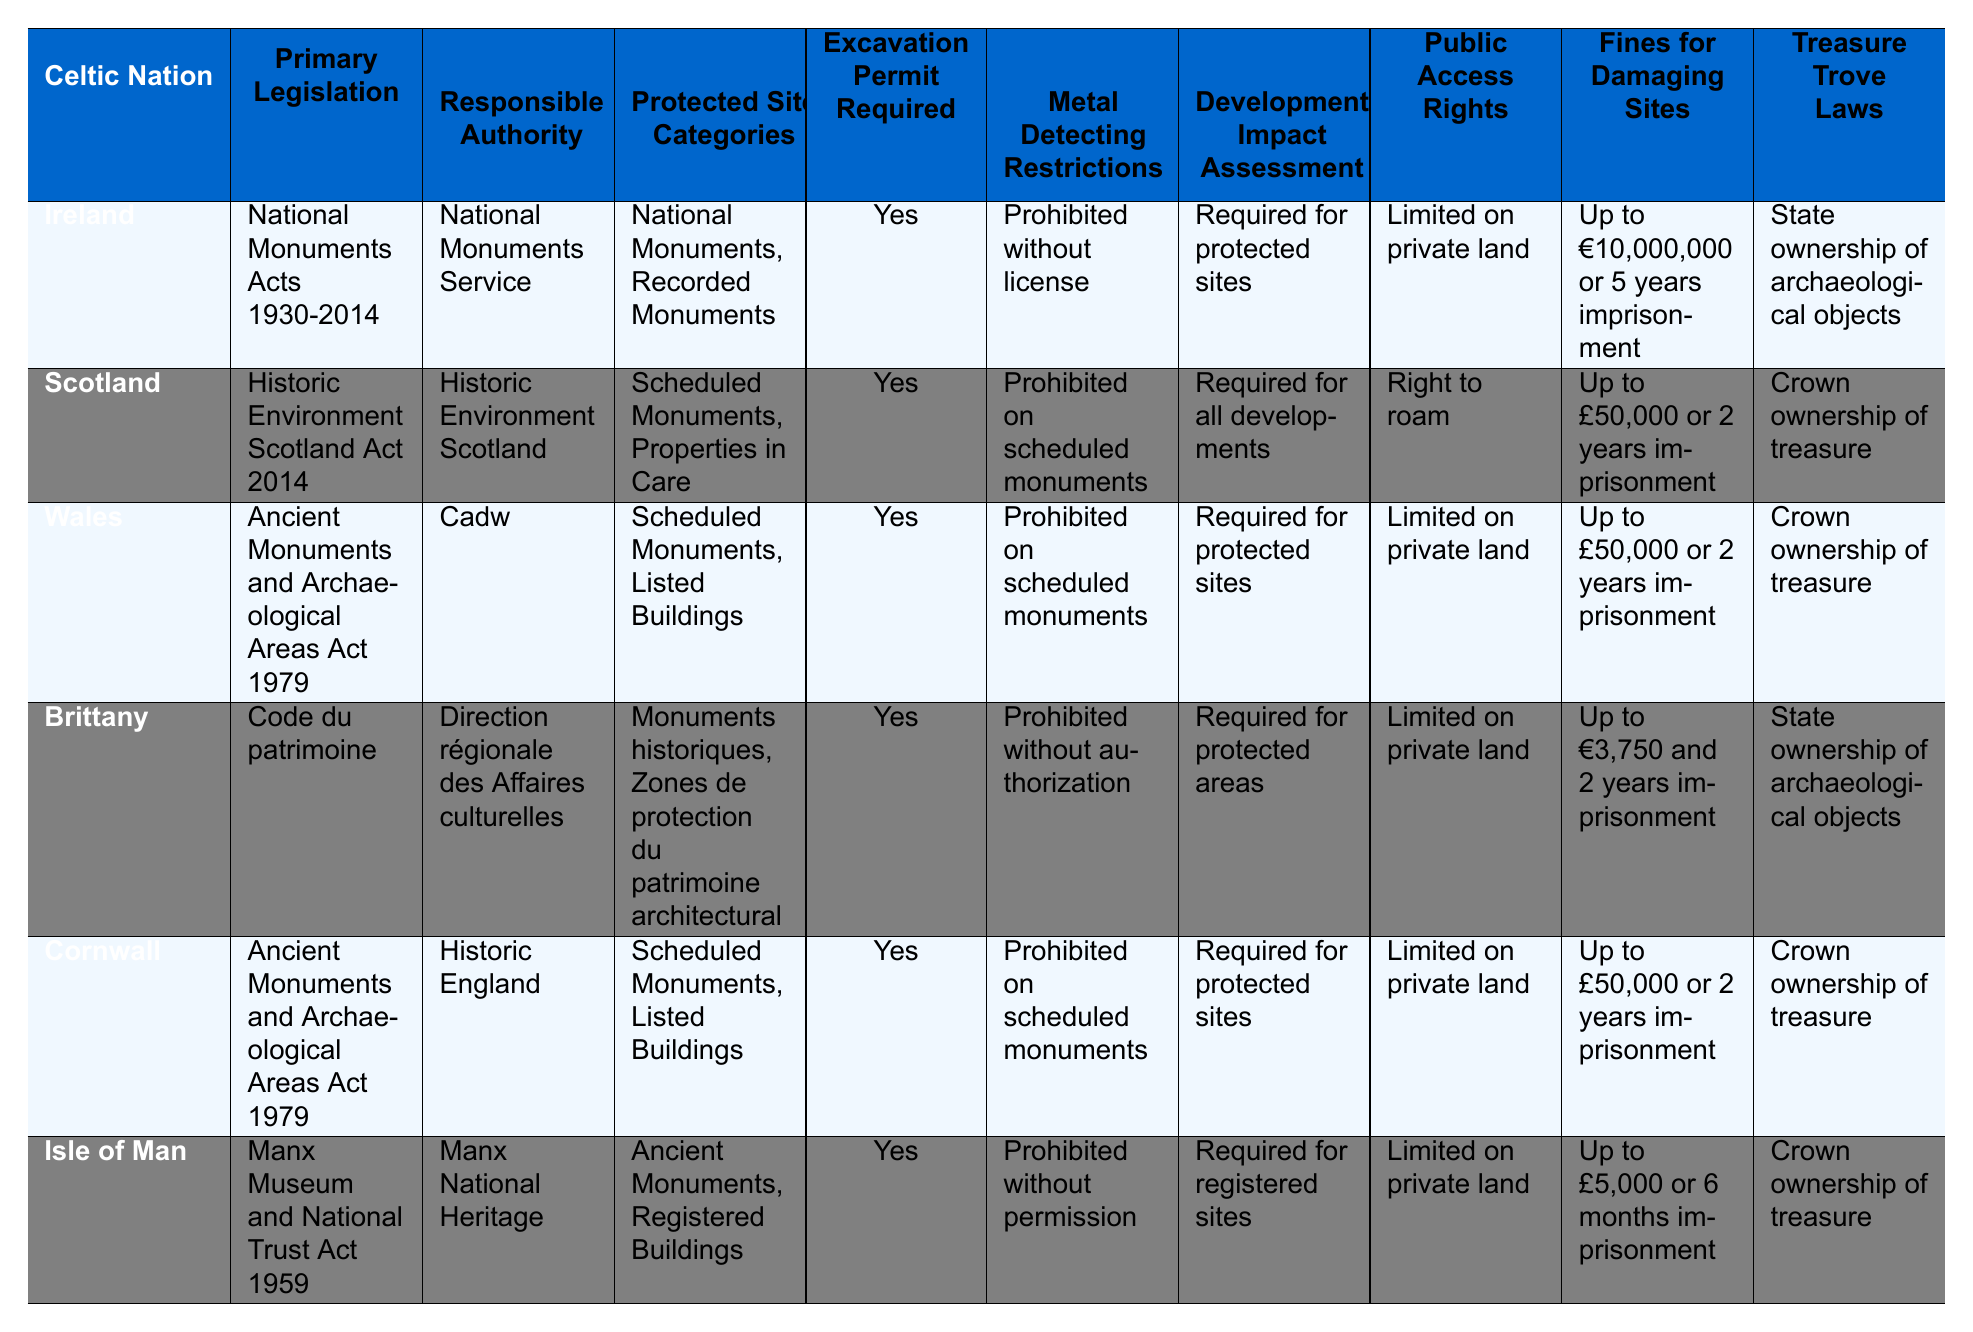What is the primary legislation for protecting archaeological sites in Ireland? The table lists "National Monuments Acts 1930-2014" under the "Primary Legislation" column for Ireland.
Answer: National Monuments Acts 1930-2014 Which Celtic nation has metal detecting restrictions that are "Prohibited without authorization"? In the table, Brittany is indicated to have metal detecting restrictions categorized as "Prohibited without authorization".
Answer: Brittany How many Celtic nations require an excavation permit for archaeological sites? The table shows that all Celtic nations require an excavation permit, as indicated by "Yes" in that column. Since there are six nations, the total is 6.
Answer: 6 What are the fines for damaging archaeological sites in Cornwall? The table states that the fines for damaging sites in Cornwall are "Up to £50,000 or 2 years imprisonment".
Answer: Up to £50,000 or 2 years imprisonment In which Celtic nation is there a right to roam? The table indicates that Scotland is the only Celtic nation listed with "Right to roam" under the "Public Access Rights" column.
Answer: Scotland Which Celtic nation has the least severe fines for damaging archaeological sites? Comparing the fines detailed in the table, the least severe fines belong to the Isle of Man, which states "Up to £5,000 or 6 months imprisonment". This is lower than all other fines listed.
Answer: Isle of Man Do all Celtic nations have the same requirements for development impact assessment? Looking at the table, it shows that while some nations have similar requirements, they are not all the same. Ireland, Wales, and Cornwall require it for protected sites, Scotland for all developments, Brittany for protected areas, and the Isle of Man for registered sites.
Answer: No What is the commonality in treasure trove laws among most Celtic nations? The table shows that all nations except Ireland and Brittany have "Crown ownership of treasure" under their treasure trove laws. Ireland and Brittany state "State ownership of archaeological objects" instead.
Answer: Most Celtic nations have Crown ownership of treasure How do public access rights vary among the Celtic nations? By examining the table, one can see that most Celtic nations (Ireland, Wales, Brittany, Cornwall, and the Isle of Man) have "Limited on private land," while Scotland enjoys "Right to roam". This illustrates a significant difference in public access rights.
Answer: They vary, with Scotland having full access rights 